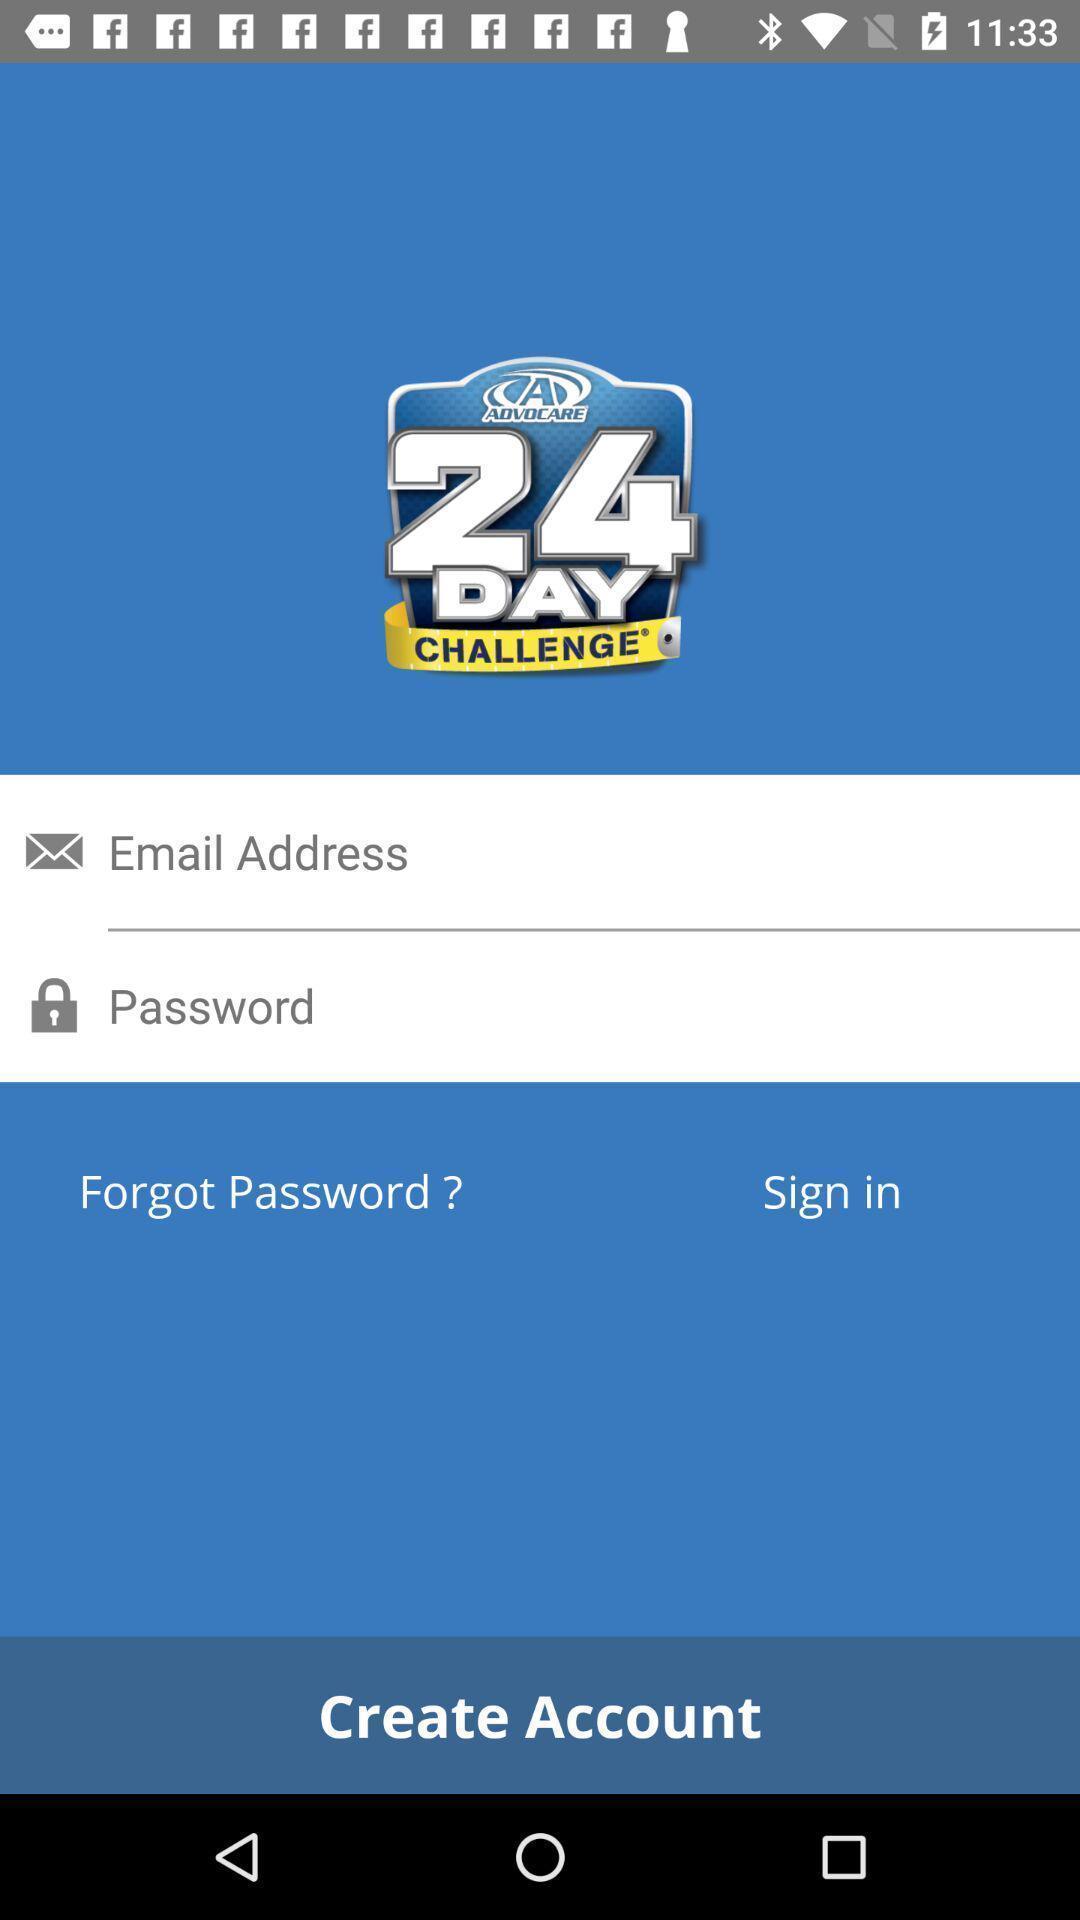Please provide a description for this image. Window displaying a login page. 